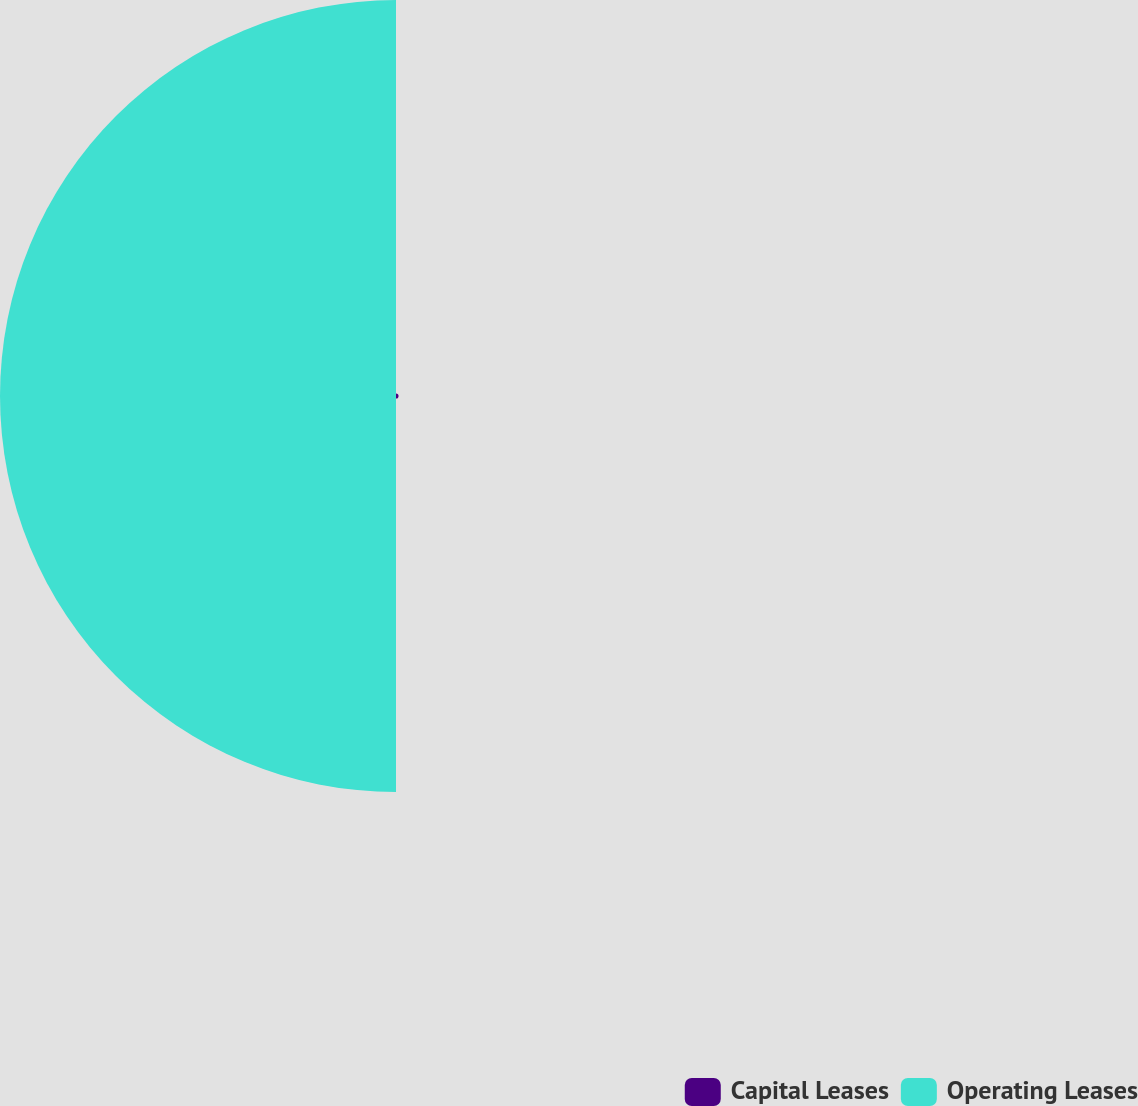<chart> <loc_0><loc_0><loc_500><loc_500><pie_chart><fcel>Capital Leases<fcel>Operating Leases<nl><fcel>0.64%<fcel>99.36%<nl></chart> 